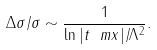<formula> <loc_0><loc_0><loc_500><loc_500>\Delta \sigma / \sigma \sim \frac { 1 } { \ln | t _ { \ } m x | / \Lambda ^ { 2 } } .</formula> 